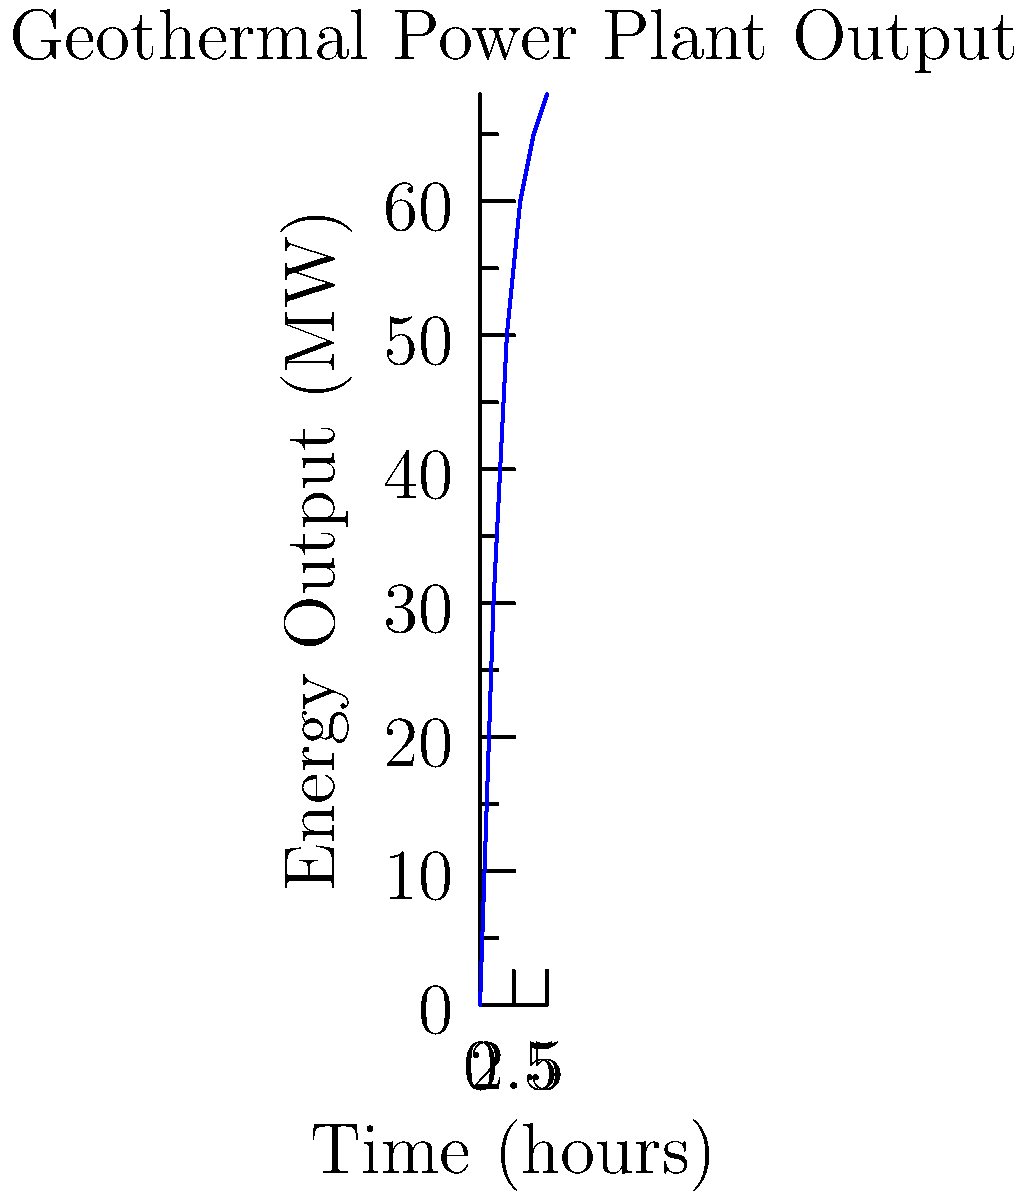As a travel blogger exploring Indonesia's renewable energy initiatives, you visit a geothermal power plant in Sarulla, North Sumatra. The plant engineer shows you the energy output graph above. If the plant operates continuously for 24 hours, what is the total energy produced in megawatt-hours (MWh)? To calculate the total energy produced, we need to follow these steps:

1. Understand the graph:
   - The x-axis represents time in hours
   - The y-axis represents energy output in MW

2. Estimate the average power output:
   - At t=0h, output is 0 MW
   - At t=5h, output is approximately 68 MW
   - The curve seems to stabilize around 68 MW

3. Calculate the average power output:
   - Approximate average = (0 MW + 68 MW) / 2 = 34 MW

4. Calculate total energy produced:
   - Energy = Power × Time
   - Time of operation = 24 hours
   - Total Energy = 34 MW × 24 h = 816 MWh

Therefore, the total energy produced in 24 hours is approximately 816 MWh.
Answer: 816 MWh 